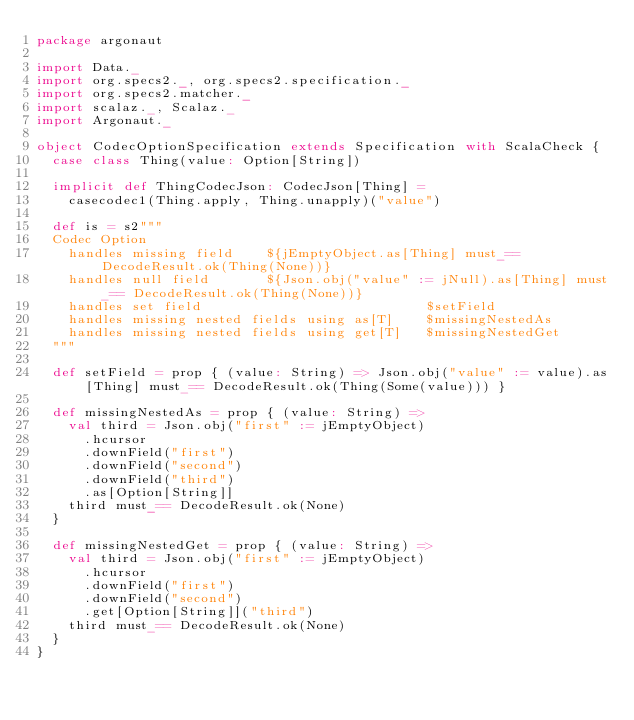<code> <loc_0><loc_0><loc_500><loc_500><_Scala_>package argonaut

import Data._
import org.specs2._, org.specs2.specification._
import org.specs2.matcher._
import scalaz._, Scalaz._
import Argonaut._

object CodecOptionSpecification extends Specification with ScalaCheck {
  case class Thing(value: Option[String])

  implicit def ThingCodecJson: CodecJson[Thing] =
    casecodec1(Thing.apply, Thing.unapply)("value")

  def is = s2"""
  Codec Option
    handles missing field    ${jEmptyObject.as[Thing] must_== DecodeResult.ok(Thing(None))}
    handles null field       ${Json.obj("value" := jNull).as[Thing] must_== DecodeResult.ok(Thing(None))}
    handles set field                            $setField
    handles missing nested fields using as[T]    $missingNestedAs
    handles missing nested fields using get[T]   $missingNestedGet
  """

  def setField = prop { (value: String) => Json.obj("value" := value).as[Thing] must_== DecodeResult.ok(Thing(Some(value))) }

  def missingNestedAs = prop { (value: String) =>
    val third = Json.obj("first" := jEmptyObject)
      .hcursor
      .downField("first")
      .downField("second")
      .downField("third")
      .as[Option[String]]
    third must_== DecodeResult.ok(None)
  }

  def missingNestedGet = prop { (value: String) =>
    val third = Json.obj("first" := jEmptyObject)
      .hcursor
      .downField("first")
      .downField("second")
      .get[Option[String]]("third")
    third must_== DecodeResult.ok(None)
  }
}
</code> 